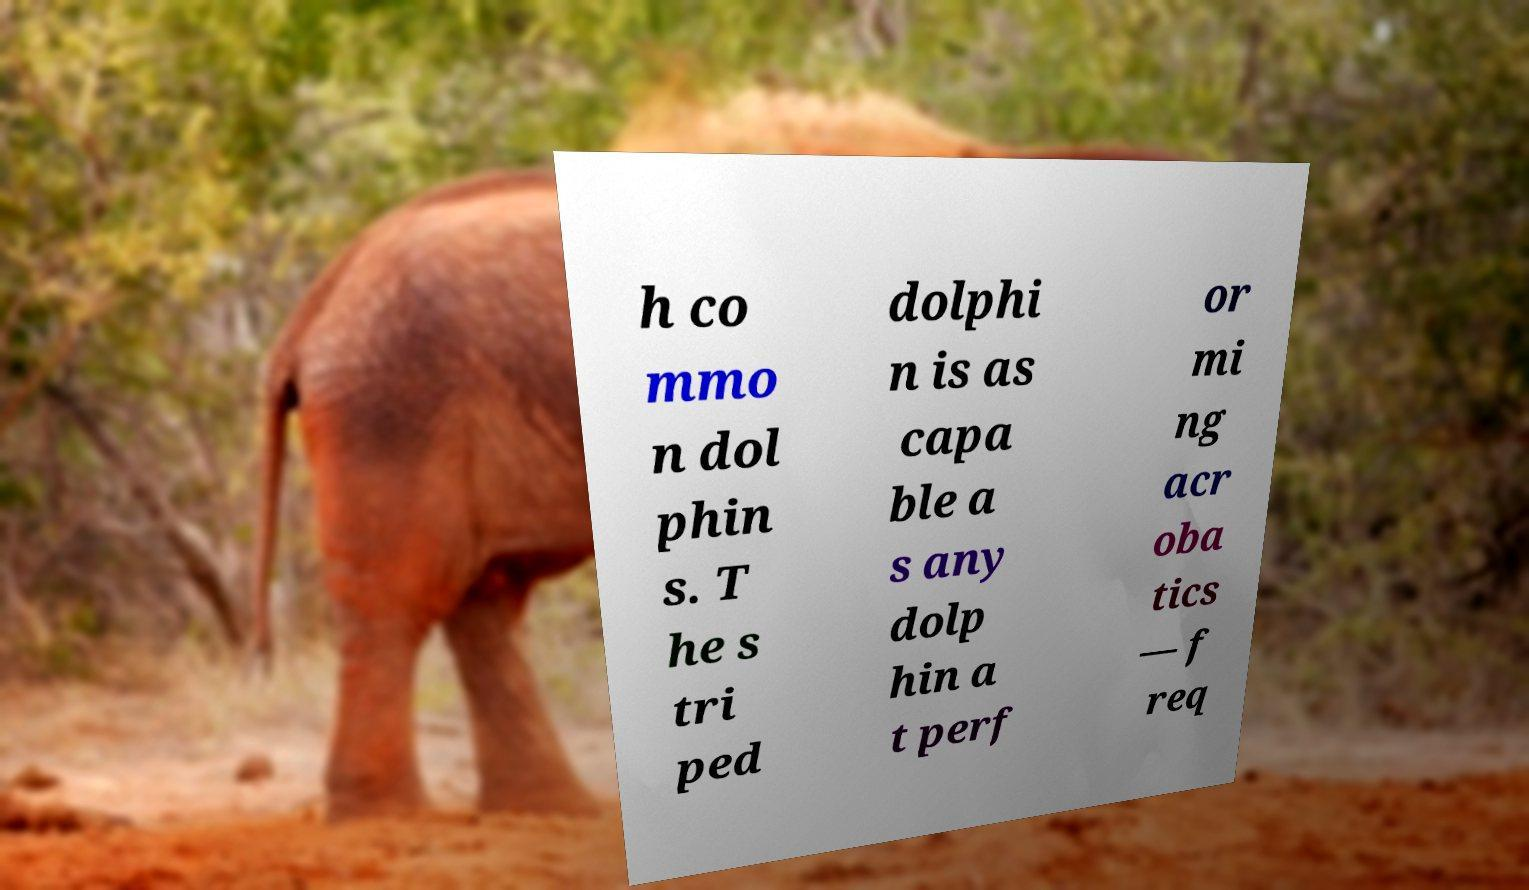I need the written content from this picture converted into text. Can you do that? h co mmo n dol phin s. T he s tri ped dolphi n is as capa ble a s any dolp hin a t perf or mi ng acr oba tics — f req 